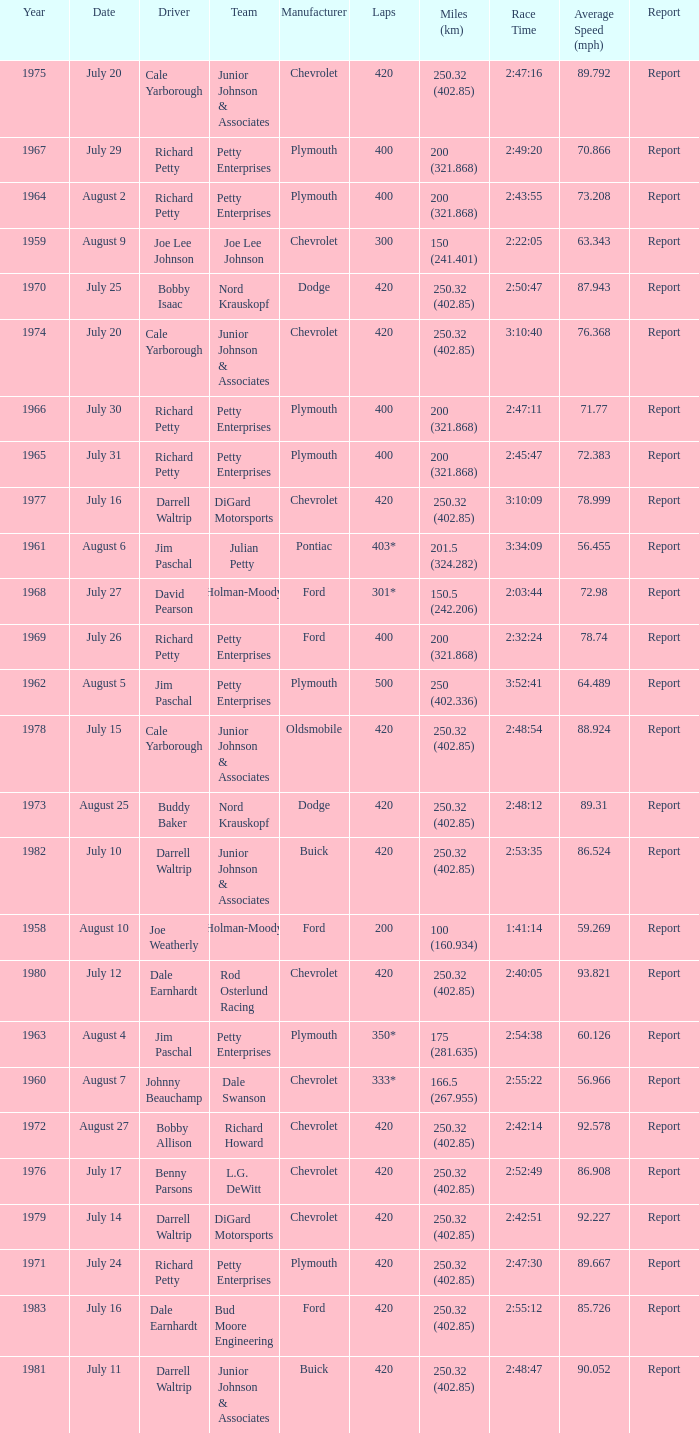Would you mind parsing the complete table? {'header': ['Year', 'Date', 'Driver', 'Team', 'Manufacturer', 'Laps', 'Miles (km)', 'Race Time', 'Average Speed (mph)', 'Report'], 'rows': [['1975', 'July 20', 'Cale Yarborough', 'Junior Johnson & Associates', 'Chevrolet', '420', '250.32 (402.85)', '2:47:16', '89.792', 'Report'], ['1967', 'July 29', 'Richard Petty', 'Petty Enterprises', 'Plymouth', '400', '200 (321.868)', '2:49:20', '70.866', 'Report'], ['1964', 'August 2', 'Richard Petty', 'Petty Enterprises', 'Plymouth', '400', '200 (321.868)', '2:43:55', '73.208', 'Report'], ['1959', 'August 9', 'Joe Lee Johnson', 'Joe Lee Johnson', 'Chevrolet', '300', '150 (241.401)', '2:22:05', '63.343', 'Report'], ['1970', 'July 25', 'Bobby Isaac', 'Nord Krauskopf', 'Dodge', '420', '250.32 (402.85)', '2:50:47', '87.943', 'Report'], ['1974', 'July 20', 'Cale Yarborough', 'Junior Johnson & Associates', 'Chevrolet', '420', '250.32 (402.85)', '3:10:40', '76.368', 'Report'], ['1966', 'July 30', 'Richard Petty', 'Petty Enterprises', 'Plymouth', '400', '200 (321.868)', '2:47:11', '71.77', 'Report'], ['1965', 'July 31', 'Richard Petty', 'Petty Enterprises', 'Plymouth', '400', '200 (321.868)', '2:45:47', '72.383', 'Report'], ['1977', 'July 16', 'Darrell Waltrip', 'DiGard Motorsports', 'Chevrolet', '420', '250.32 (402.85)', '3:10:09', '78.999', 'Report'], ['1961', 'August 6', 'Jim Paschal', 'Julian Petty', 'Pontiac', '403*', '201.5 (324.282)', '3:34:09', '56.455', 'Report'], ['1968', 'July 27', 'David Pearson', 'Holman-Moody', 'Ford', '301*', '150.5 (242.206)', '2:03:44', '72.98', 'Report'], ['1969', 'July 26', 'Richard Petty', 'Petty Enterprises', 'Ford', '400', '200 (321.868)', '2:32:24', '78.74', 'Report'], ['1962', 'August 5', 'Jim Paschal', 'Petty Enterprises', 'Plymouth', '500', '250 (402.336)', '3:52:41', '64.489', 'Report'], ['1978', 'July 15', 'Cale Yarborough', 'Junior Johnson & Associates', 'Oldsmobile', '420', '250.32 (402.85)', '2:48:54', '88.924', 'Report'], ['1973', 'August 25', 'Buddy Baker', 'Nord Krauskopf', 'Dodge', '420', '250.32 (402.85)', '2:48:12', '89.31', 'Report'], ['1982', 'July 10', 'Darrell Waltrip', 'Junior Johnson & Associates', 'Buick', '420', '250.32 (402.85)', '2:53:35', '86.524', 'Report'], ['1958', 'August 10', 'Joe Weatherly', 'Holman-Moody', 'Ford', '200', '100 (160.934)', '1:41:14', '59.269', 'Report'], ['1980', 'July 12', 'Dale Earnhardt', 'Rod Osterlund Racing', 'Chevrolet', '420', '250.32 (402.85)', '2:40:05', '93.821', 'Report'], ['1963', 'August 4', 'Jim Paschal', 'Petty Enterprises', 'Plymouth', '350*', '175 (281.635)', '2:54:38', '60.126', 'Report'], ['1960', 'August 7', 'Johnny Beauchamp', 'Dale Swanson', 'Chevrolet', '333*', '166.5 (267.955)', '2:55:22', '56.966', 'Report'], ['1972', 'August 27', 'Bobby Allison', 'Richard Howard', 'Chevrolet', '420', '250.32 (402.85)', '2:42:14', '92.578', 'Report'], ['1976', 'July 17', 'Benny Parsons', 'L.G. DeWitt', 'Chevrolet', '420', '250.32 (402.85)', '2:52:49', '86.908', 'Report'], ['1979', 'July 14', 'Darrell Waltrip', 'DiGard Motorsports', 'Chevrolet', '420', '250.32 (402.85)', '2:42:51', '92.227', 'Report'], ['1971', 'July 24', 'Richard Petty', 'Petty Enterprises', 'Plymouth', '420', '250.32 (402.85)', '2:47:30', '89.667', 'Report'], ['1983', 'July 16', 'Dale Earnhardt', 'Bud Moore Engineering', 'Ford', '420', '250.32 (402.85)', '2:55:12', '85.726', 'Report'], ['1981', 'July 11', 'Darrell Waltrip', 'Junior Johnson & Associates', 'Buick', '420', '250.32 (402.85)', '2:48:47', '90.052', 'Report']]} How many miles were driven in the race where the winner finished in 2:47:11? 200 (321.868). 